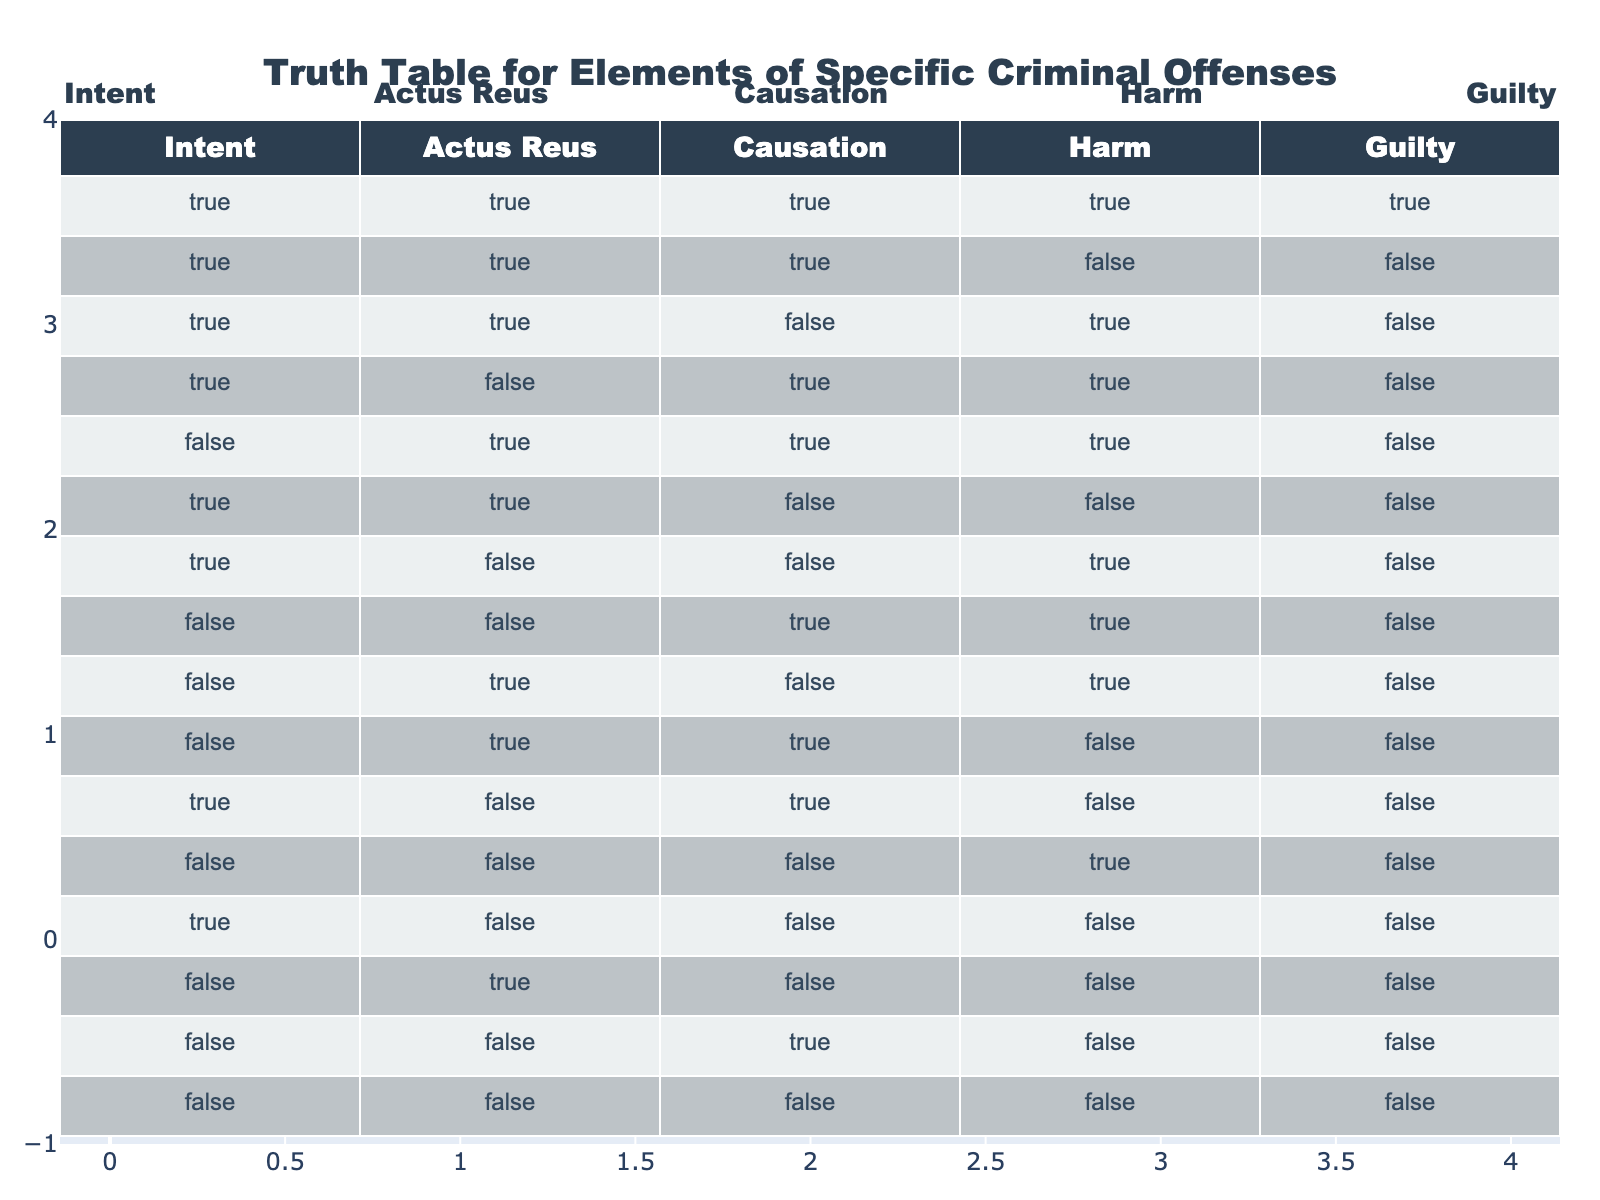What is the only scenario where all elements (Intent, Actus Reus, Causation, Harm) are true? According to the table, the only scenario where all four elements are true occurs in the first row. Here, Intent, Actus Reus, Causation, and Harm are all indicated as true, leading to a guilty verdict in that scenario.
Answer: True How many rows indicate a guilty verdict? To find the number of rows indicating a guilty verdict, we count the number of rows where the 'Guilty' column is true. There is only one row (the first one) where Guilty is true, hence the count is one.
Answer: 1 Is there any scenario where Intent is false but Harm is true? By scanning through the table, the fifth row shows that Intent is false while Harm is true, confirming this situation does exist in the table.
Answer: Yes What is the total number of scenarios with true Actus Reus? We examine the 'Actus Reus' column and count all rows that contain true. This occurs in six scenarios (the first, second, third, fourth, fifth, and tenth rows). Thus, the total is six.
Answer: 6 In how many cases does Causation lead to a guilty verdict when Intent is true? For this, we look at the rows where both Intent and Causation are true. The first row meets these criteria, resulting in a guilty verdict. Hence, there is only one case where both conditions lead to a guilty verdict.
Answer: 1 How does the number of scenarios with true Harm compare to those with true Intent? We first count scenarios with true Harm (5 total) and then compare it to Intent (6 total). The number of scenarios with true Harm is less than those with true Intent. Therefore, there are more true Intent scenarios than true Harm scenarios.
Answer: Harm < Intent What percentage of the scenarios with false Actus Reus results in a guilty verdict? We identify the rows where Actus Reus is false (in total 8 rows) and check if any of these rows also indicate a guilty verdict. None of the 8 rows result in a guilty verdict, leading to the conclusion that 0% of scenarios with false Actus Reus result in a guilty verdict.
Answer: 0% How many scenarios involve both true Intent and false Harm? Looking through the table, scenarios involving true Intent and false Harm occur in three rows: the third, sixth, and twelfth, bringing the total to three.
Answer: 3 Given that Intent is true, what is the combined count of rows where Causation and Harm are both false? We need to examine only the rows where Intent is true (6 rows). Among these, only the sixth and thirteenth rows have Causation and Harm marked as false. Therefore, the total count of such rows is two.
Answer: 2 